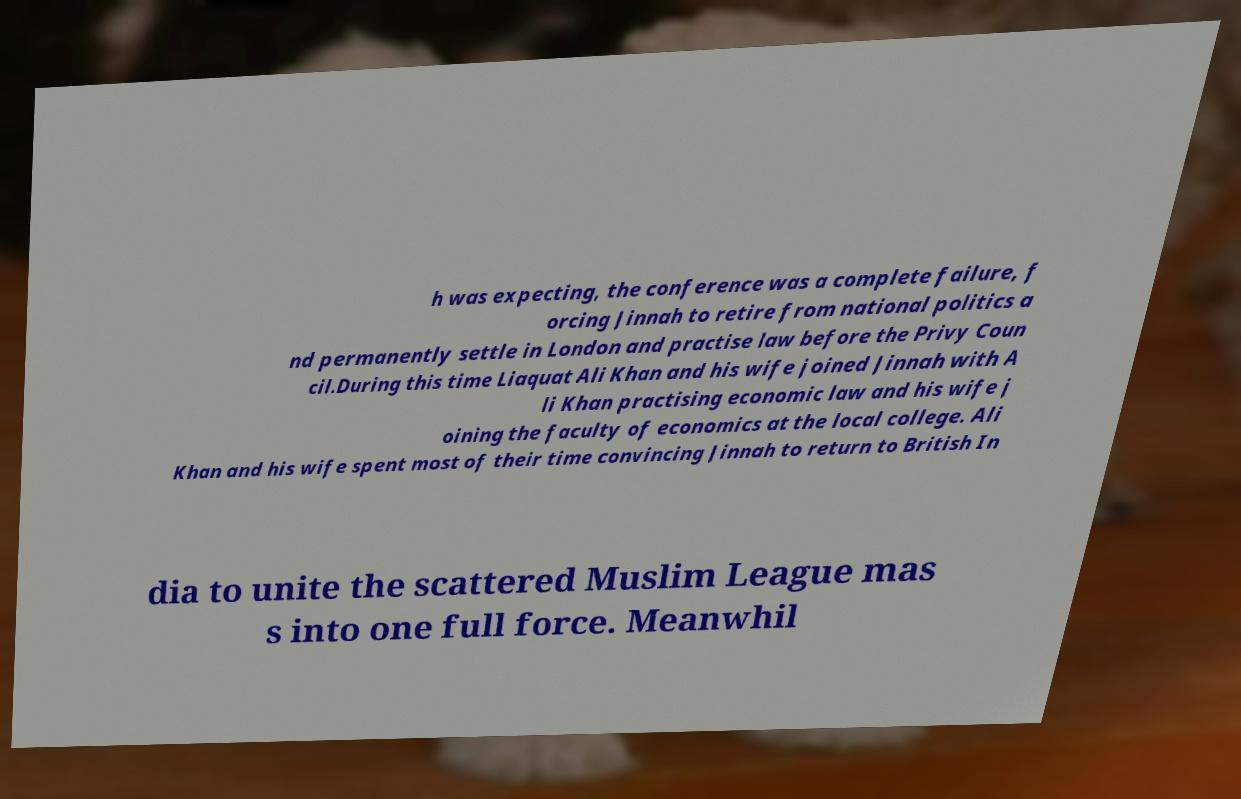Please identify and transcribe the text found in this image. h was expecting, the conference was a complete failure, f orcing Jinnah to retire from national politics a nd permanently settle in London and practise law before the Privy Coun cil.During this time Liaquat Ali Khan and his wife joined Jinnah with A li Khan practising economic law and his wife j oining the faculty of economics at the local college. Ali Khan and his wife spent most of their time convincing Jinnah to return to British In dia to unite the scattered Muslim League mas s into one full force. Meanwhil 